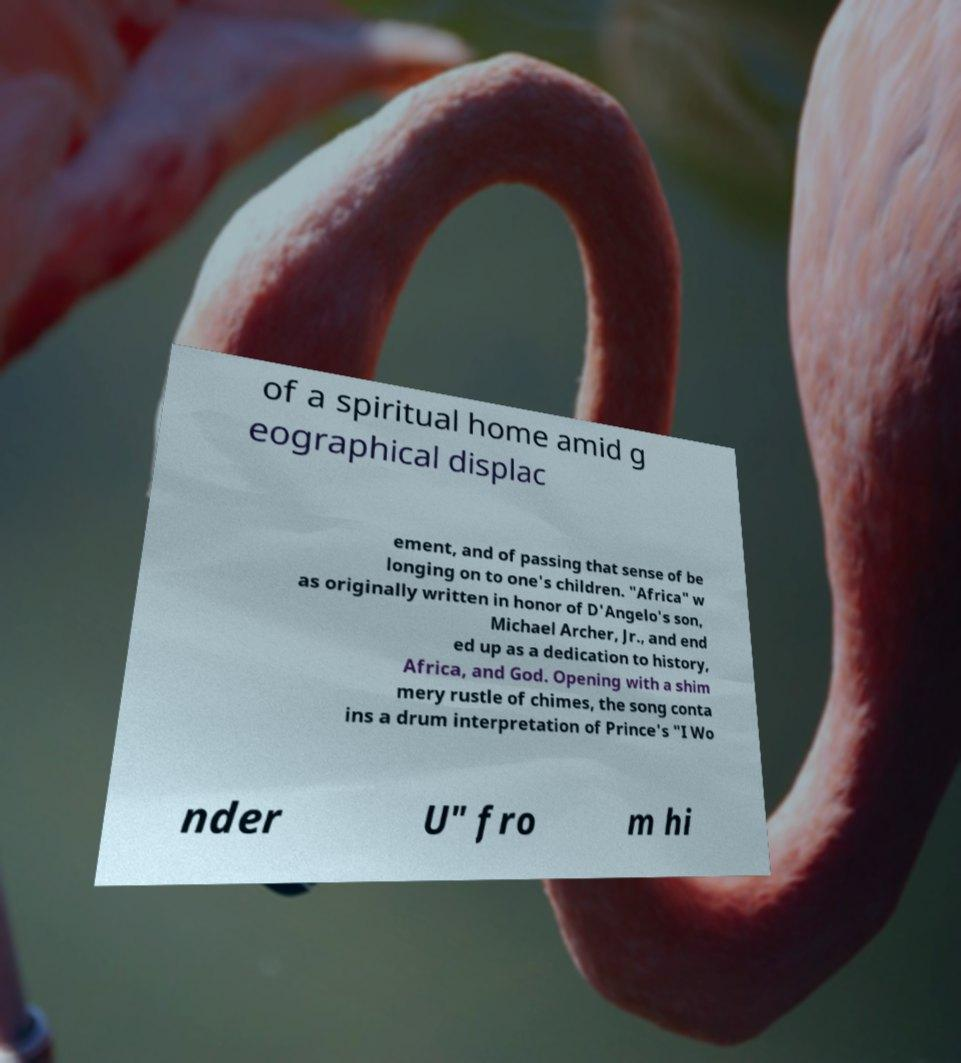I need the written content from this picture converted into text. Can you do that? of a spiritual home amid g eographical displac ement, and of passing that sense of be longing on to one's children. "Africa" w as originally written in honor of D'Angelo's son, Michael Archer, Jr., and end ed up as a dedication to history, Africa, and God. Opening with a shim mery rustle of chimes, the song conta ins a drum interpretation of Prince's "I Wo nder U" fro m hi 